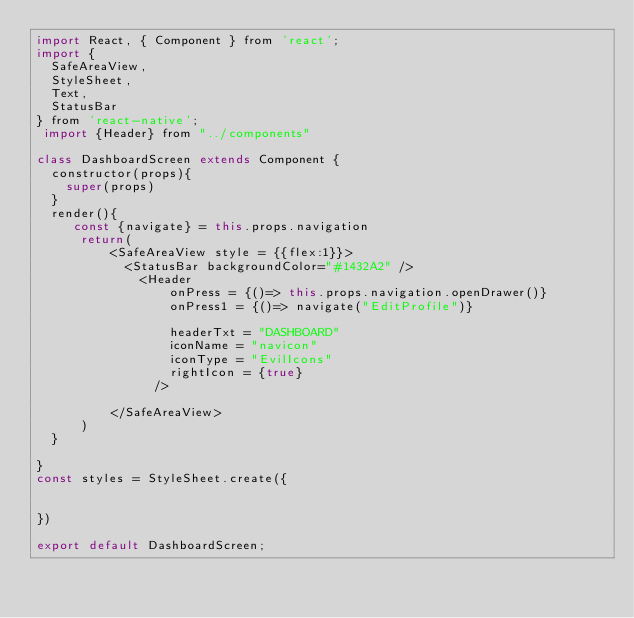Convert code to text. <code><loc_0><loc_0><loc_500><loc_500><_JavaScript_>import React, { Component } from 'react';
import {
  SafeAreaView,
  StyleSheet,
  Text,
  StatusBar
} from 'react-native';
 import {Header} from "../components"

class DashboardScreen extends Component { 
  constructor(props){
    super(props)
  }
  render(){
     const {navigate} = this.props.navigation
      return(
          <SafeAreaView style = {{flex:1}}>
            <StatusBar backgroundColor="#1432A2" /> 
              <Header
                  onPress = {()=> this.props.navigation.openDrawer()}
                  onPress1 = {()=> navigate("EditProfile")}
                 
                  headerTxt = "DASHBOARD"
                  iconName = "navicon"
                  iconType = "EvilIcons"
                  rightIcon = {true}
                />

          </SafeAreaView>
      )
  }

}
const styles = StyleSheet.create({ 
 
  
})

export default DashboardScreen;
</code> 